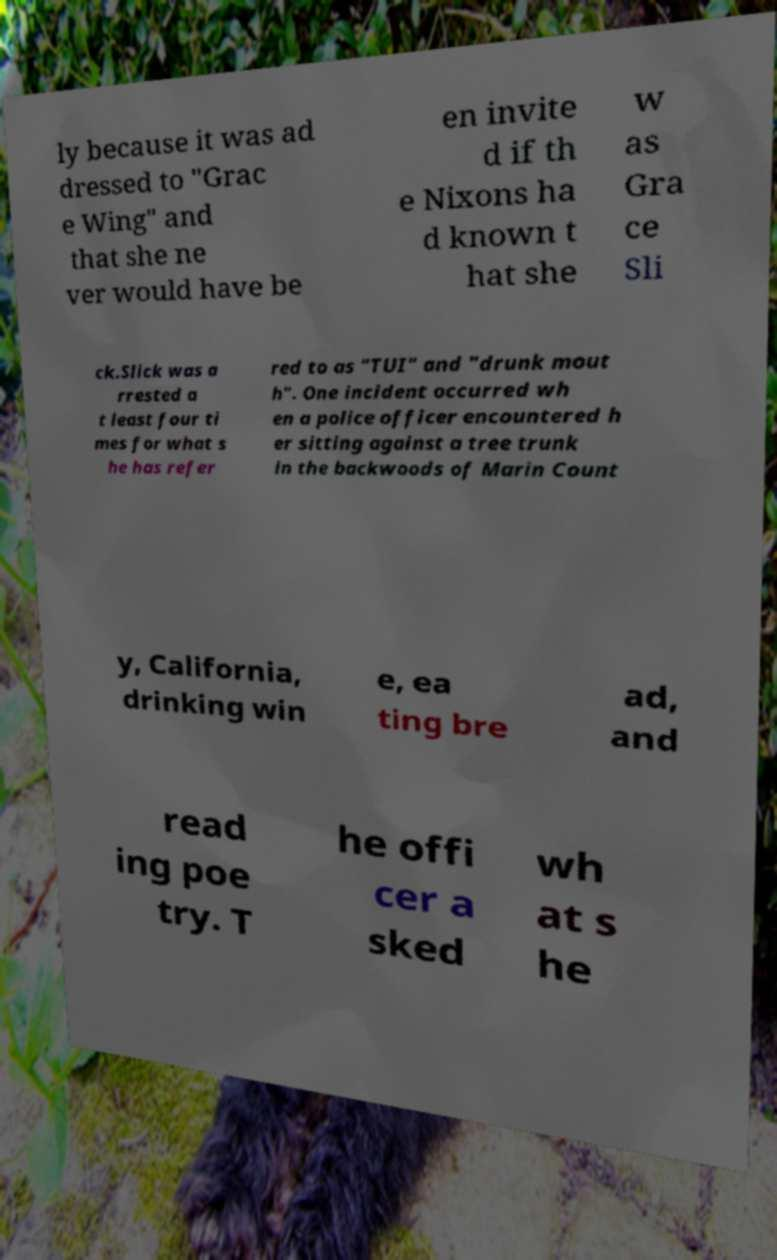For documentation purposes, I need the text within this image transcribed. Could you provide that? ly because it was ad dressed to "Grac e Wing" and that she ne ver would have be en invite d if th e Nixons ha d known t hat she w as Gra ce Sli ck.Slick was a rrested a t least four ti mes for what s he has refer red to as "TUI" and "drunk mout h". One incident occurred wh en a police officer encountered h er sitting against a tree trunk in the backwoods of Marin Count y, California, drinking win e, ea ting bre ad, and read ing poe try. T he offi cer a sked wh at s he 